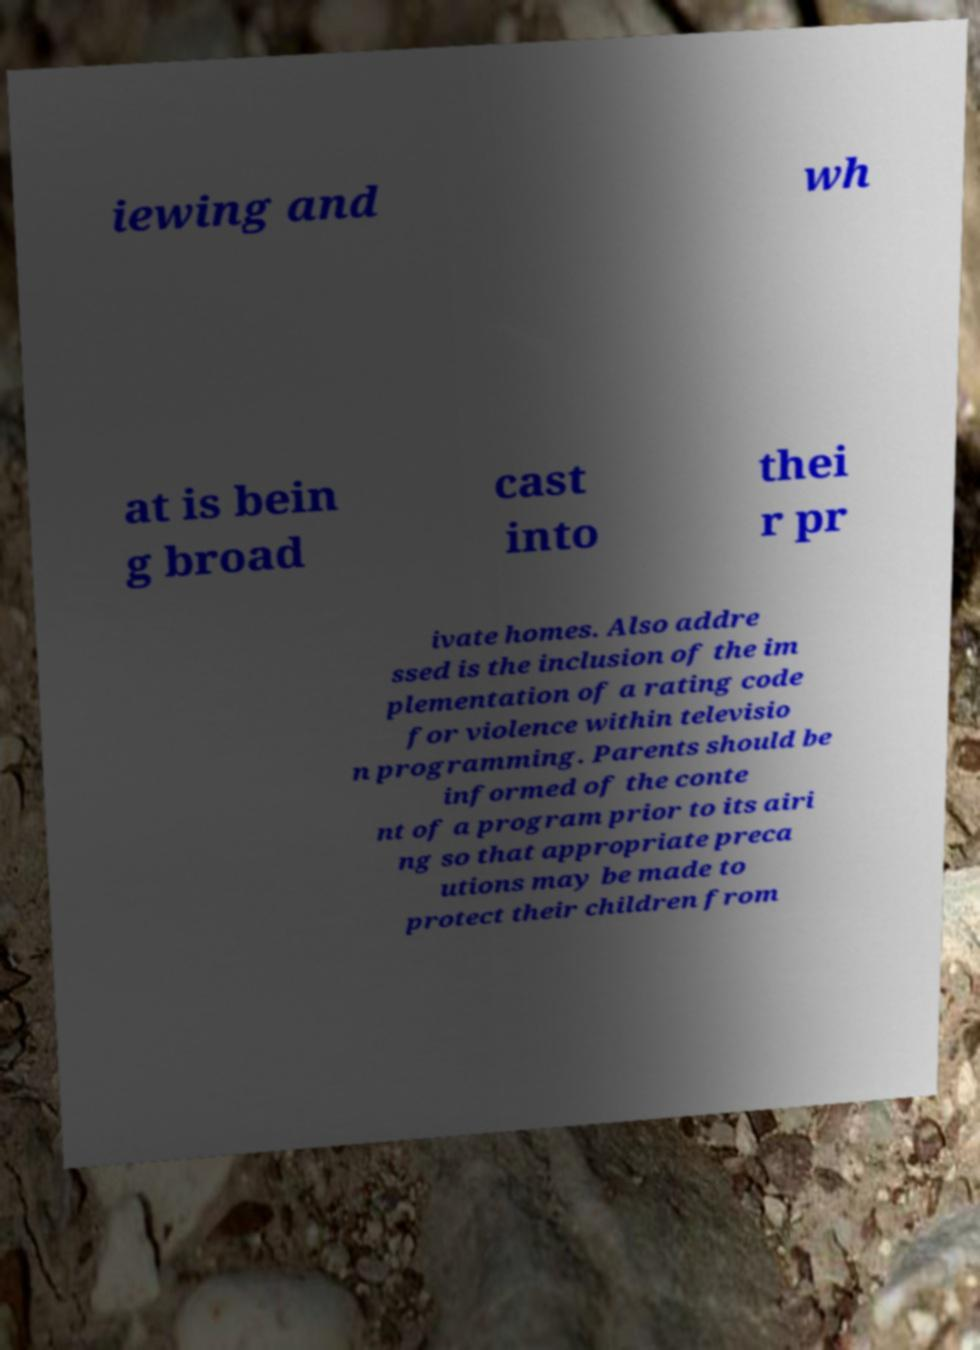What messages or text are displayed in this image? I need them in a readable, typed format. iewing and wh at is bein g broad cast into thei r pr ivate homes. Also addre ssed is the inclusion of the im plementation of a rating code for violence within televisio n programming. Parents should be informed of the conte nt of a program prior to its airi ng so that appropriate preca utions may be made to protect their children from 